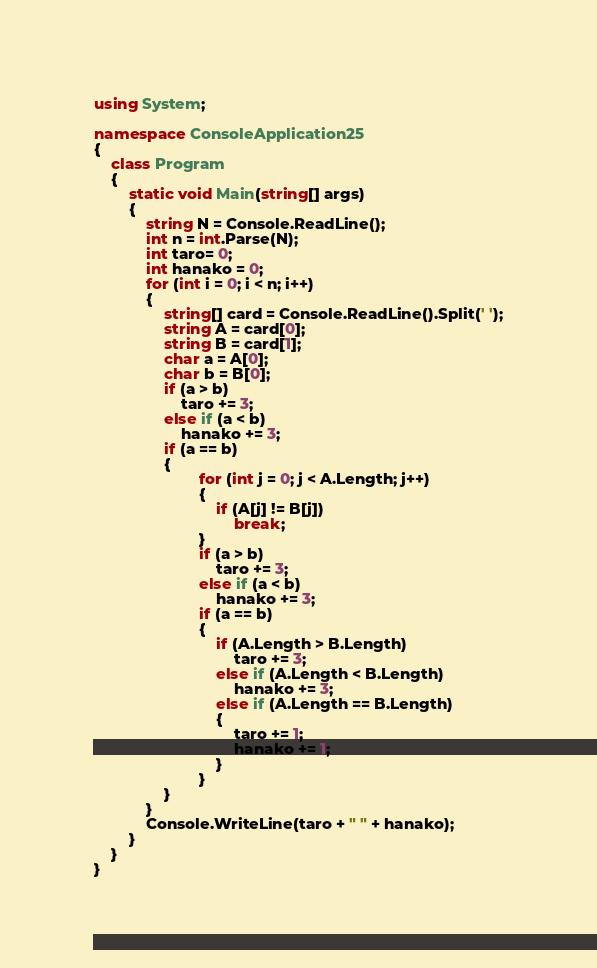<code> <loc_0><loc_0><loc_500><loc_500><_C#_>using System;

namespace ConsoleApplication25
{
    class Program
    {
        static void Main(string[] args)
        {
            string N = Console.ReadLine();
            int n = int.Parse(N);
            int taro= 0;
            int hanako = 0;
            for (int i = 0; i < n; i++)
            {
                string[] card = Console.ReadLine().Split(' ');
                string A = card[0];
                string B = card[1];
                char a = A[0];
                char b = B[0];
                if (a > b)
                    taro += 3;
                else if (a < b)
                    hanako += 3;
                if (a == b)
                {
                        for (int j = 0; j < A.Length; j++)
                        {
                            if (A[j] != B[j])
                                break;
                        }
                        if (a > b)
                            taro += 3;
                        else if (a < b)
                            hanako += 3;
                        if (a == b)
                        {
                            if (A.Length > B.Length)
                                taro += 3;
                            else if (A.Length < B.Length)
                                hanako += 3;
                            else if (A.Length == B.Length)
                            {
                                taro += 1;
                                hanako += 1;
                            }
                        }
                }
            }
            Console.WriteLine(taro + " " + hanako);
        }
    }
}</code> 